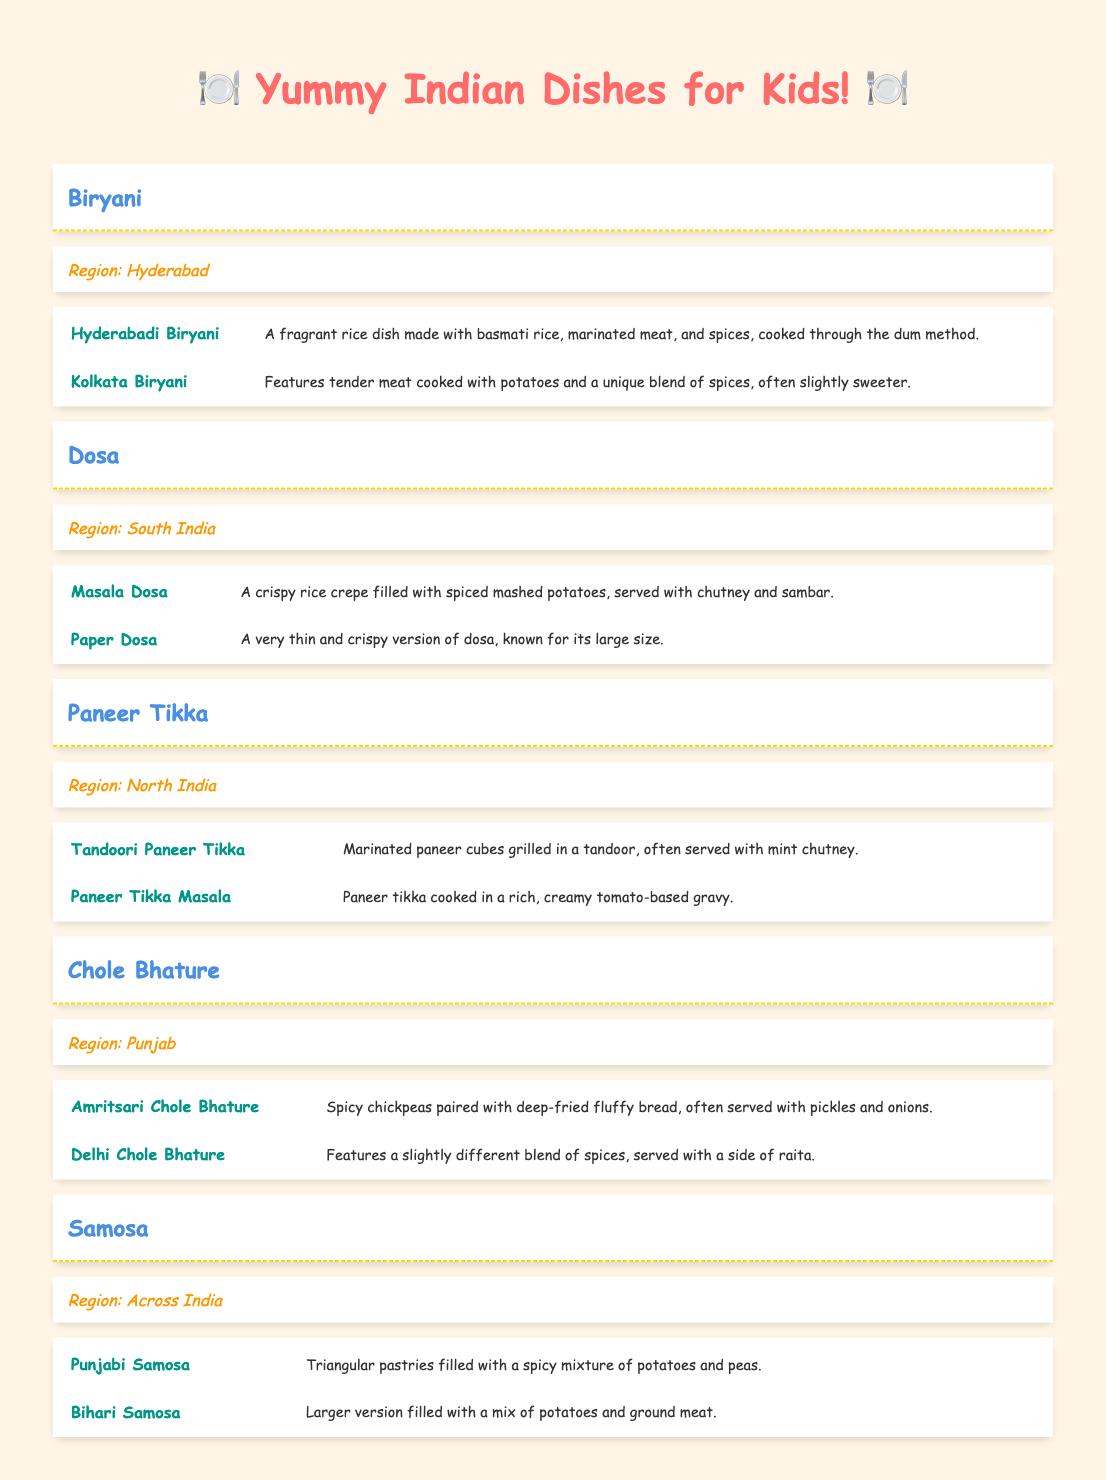What is the main ingredient in Hyderabadi Biryani? The table states that Hyderabadi Biryani is made with basmati rice, marinated meat, and spices. Therefore, the main ingredient is basmati rice.
Answer: Basmati rice How many variations of Chole Bhature are mentioned in the table? The table lists two variations of Chole Bhature: Amritsari Chole Bhature and Delhi Chole Bhature. Therefore, there are a total of 2 variations mentioned.
Answer: 2 Is Paneer Tikka cooked in a creamy sauce? According to the table, one of the variations named Paneer Tikka Masala is described as being cooked in a rich, creamy tomato-based gravy. Thus, the answer is yes.
Answer: Yes Which dish has a variation called Paper Dosa? The table shows that Paper Dosa is a variation of the dish Dosa. Therefore, Dosa is the dish that has this variation.
Answer: Dosa What are the two types of Samosas listed in the table? The table mentions two types of Samosas: Punjabi Samosa and Bihari Samosa. These names can be directly retrieved from the variations' section under Samosa.
Answer: Punjabi Samosa and Bihari Samosa Combining the regions of the dishes, which region has more than one variation listed? Looking at the table, both Biryani (Hyderabad) and Dosa (South India) have two variations each, while the other regions only have one dish. Therefore, the regions Hyderabad and South India each have more than one variation listed.
Answer: Hyderabad and South India Which dish is typically enjoyed across India? Samosa is listed with "Across India" as its region in the table, indicating that it is enjoyed in many parts of India.
Answer: Samosa Count the total number of variations listed for all dishes in the table. The table provides a total of 10 variations: 2 for Biryani, 2 for Dosa, 2 for Paneer Tikka, 2 for Chole Bhature, and 2 for Samosa, which gives us 2 + 2 + 2 + 2 + 2 = 10.
Answer: 10 What is the commonality between all variations of Samosa? The table indicates that both variations of Samosa (Punjabi Samosa and Bihari Samosa) contain a filling, which is predominantly based on potatoes. Thus, the commonality is that they are both filled pastries.
Answer: Filled pastries 